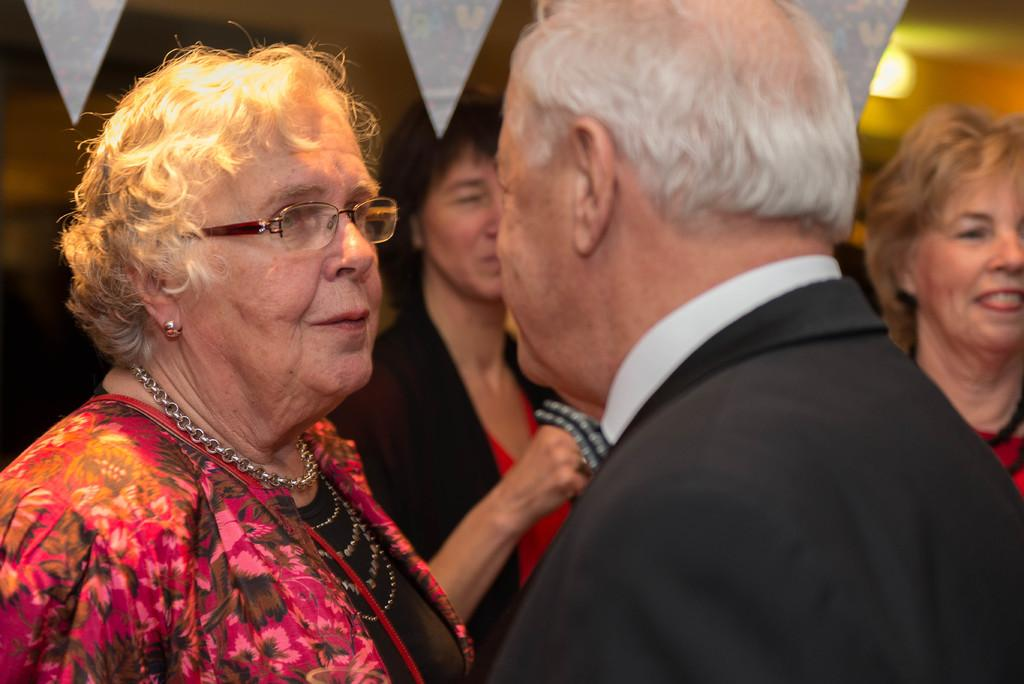How many people are present in the image? There are two people, a woman and a man, present in the image. What are the woman and man doing in the image? The woman and man are looking at each other. Are there any other people visible in the image? Yes, there are two more persons in the background of the image. How would you describe the background of the image? The background is blurred. What decision did the woman make at the airport in the image? There is no airport present in the image, and no decision-making is depicted. 